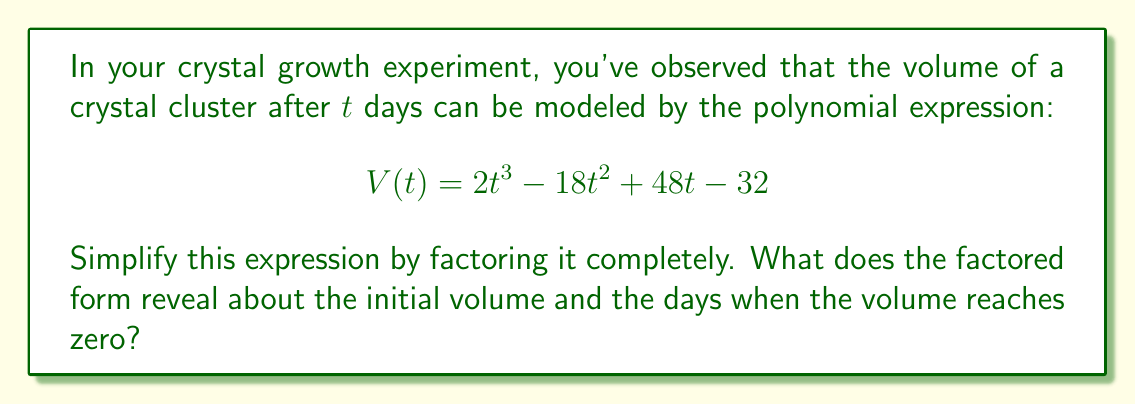Help me with this question. Let's approach this step-by-step:

1) First, we need to factor out the greatest common factor (GCF) if possible. In this case, there is no common factor for all terms.

2) Next, we can try to factor by grouping. Let's split the polynomial into two groups:

   $$ V(t) = (2t^3 - 18t^2) + (48t - 32) $$

3) Factor out the common factors from each group:

   $$ V(t) = 2t^2(t - 9) + 16(3t - 2) $$

4) Now, we need to find a common binomial factor. We can see that $(t - 9)$ might work. Let's factor it out:

   $$ V(t) = 2t^2(t - 9) + 16(3t - 2) $$
   $$ V(t) = (t - 9)(2t^2) + (t - 9)(16) + 16(2t + 7) $$
   $$ V(t) = (t - 9)(2t^2 + 16) + 16(2t + 7) $$

5) The expression $2t^2 + 16$ can be further factored as $2(t^2 + 8)$:

   $$ V(t) = (t - 9)(2(t^2 + 8)) + 16(2t + 7) $$
   $$ V(t) = 2(t - 9)(t^2 + 8) + 16(2t + 7) $$

6) Now we have a common factor of 2:

   $$ V(t) = 2((t - 9)(t^2 + 8) + 8(2t + 7)) $$

7) Simplify inside the parentheses:

   $$ V(t) = 2(t^3 - 9t^2 + 8t - 72 + 16t + 56) $$
   $$ V(t) = 2(t^3 - 9t^2 + 24t - 16) $$

8) The expression inside the parentheses is a cubic equation. Let's try to factor it:

   $$ V(t) = 2(t - 2)(t^2 - 7t + 8) $$

9) The quadratic expression $t^2 - 7t + 8$ can be factored further:

   $$ V(t) = 2(t - 2)(t - 4)(t - 3) $$

This factored form reveals that:
- The initial volume (when $t = 0$) is $V(0) = 2(-2)(-4)(-3) = -48$ cubic units.
- The volume reaches zero when $t = 2$, $t = 3$, or $t = 4$ days.
Answer: $$ V(t) = 2(t - 2)(t - 3)(t - 4) $$
Initial volume: -48 cubic units
Days when volume is zero: 2, 3, and 4 days 